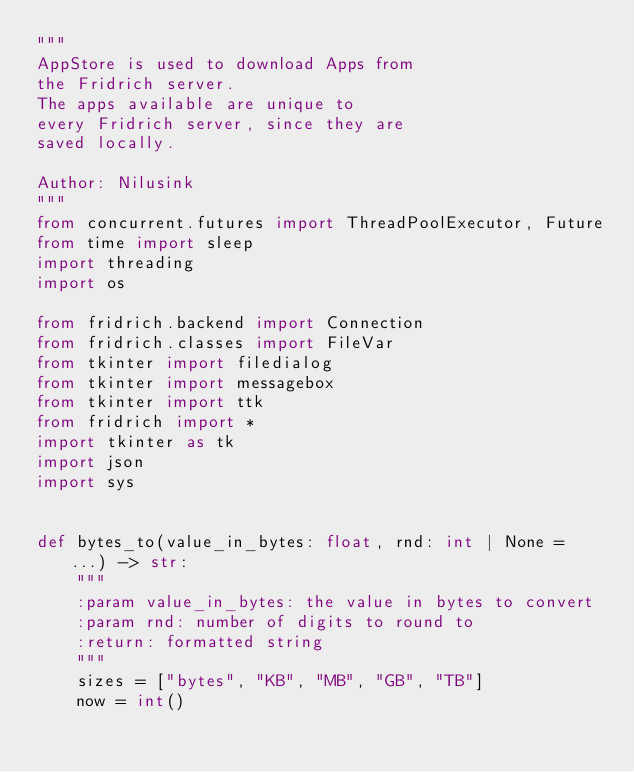<code> <loc_0><loc_0><loc_500><loc_500><_Python_>"""
AppStore is used to download Apps from
the Fridrich server.
The apps available are unique to
every Fridrich server, since they are
saved locally.

Author: Nilusink
"""
from concurrent.futures import ThreadPoolExecutor, Future
from time import sleep
import threading
import os

from fridrich.backend import Connection
from fridrich.classes import FileVar
from tkinter import filedialog
from tkinter import messagebox
from tkinter import ttk
from fridrich import *
import tkinter as tk
import json
import sys


def bytes_to(value_in_bytes: float, rnd: int | None = ...) -> str:
    """
    :param value_in_bytes: the value in bytes to convert
    :param rnd: number of digits to round to
    :return: formatted string
    """
    sizes = ["bytes", "KB", "MB", "GB", "TB"]
    now = int()</code> 